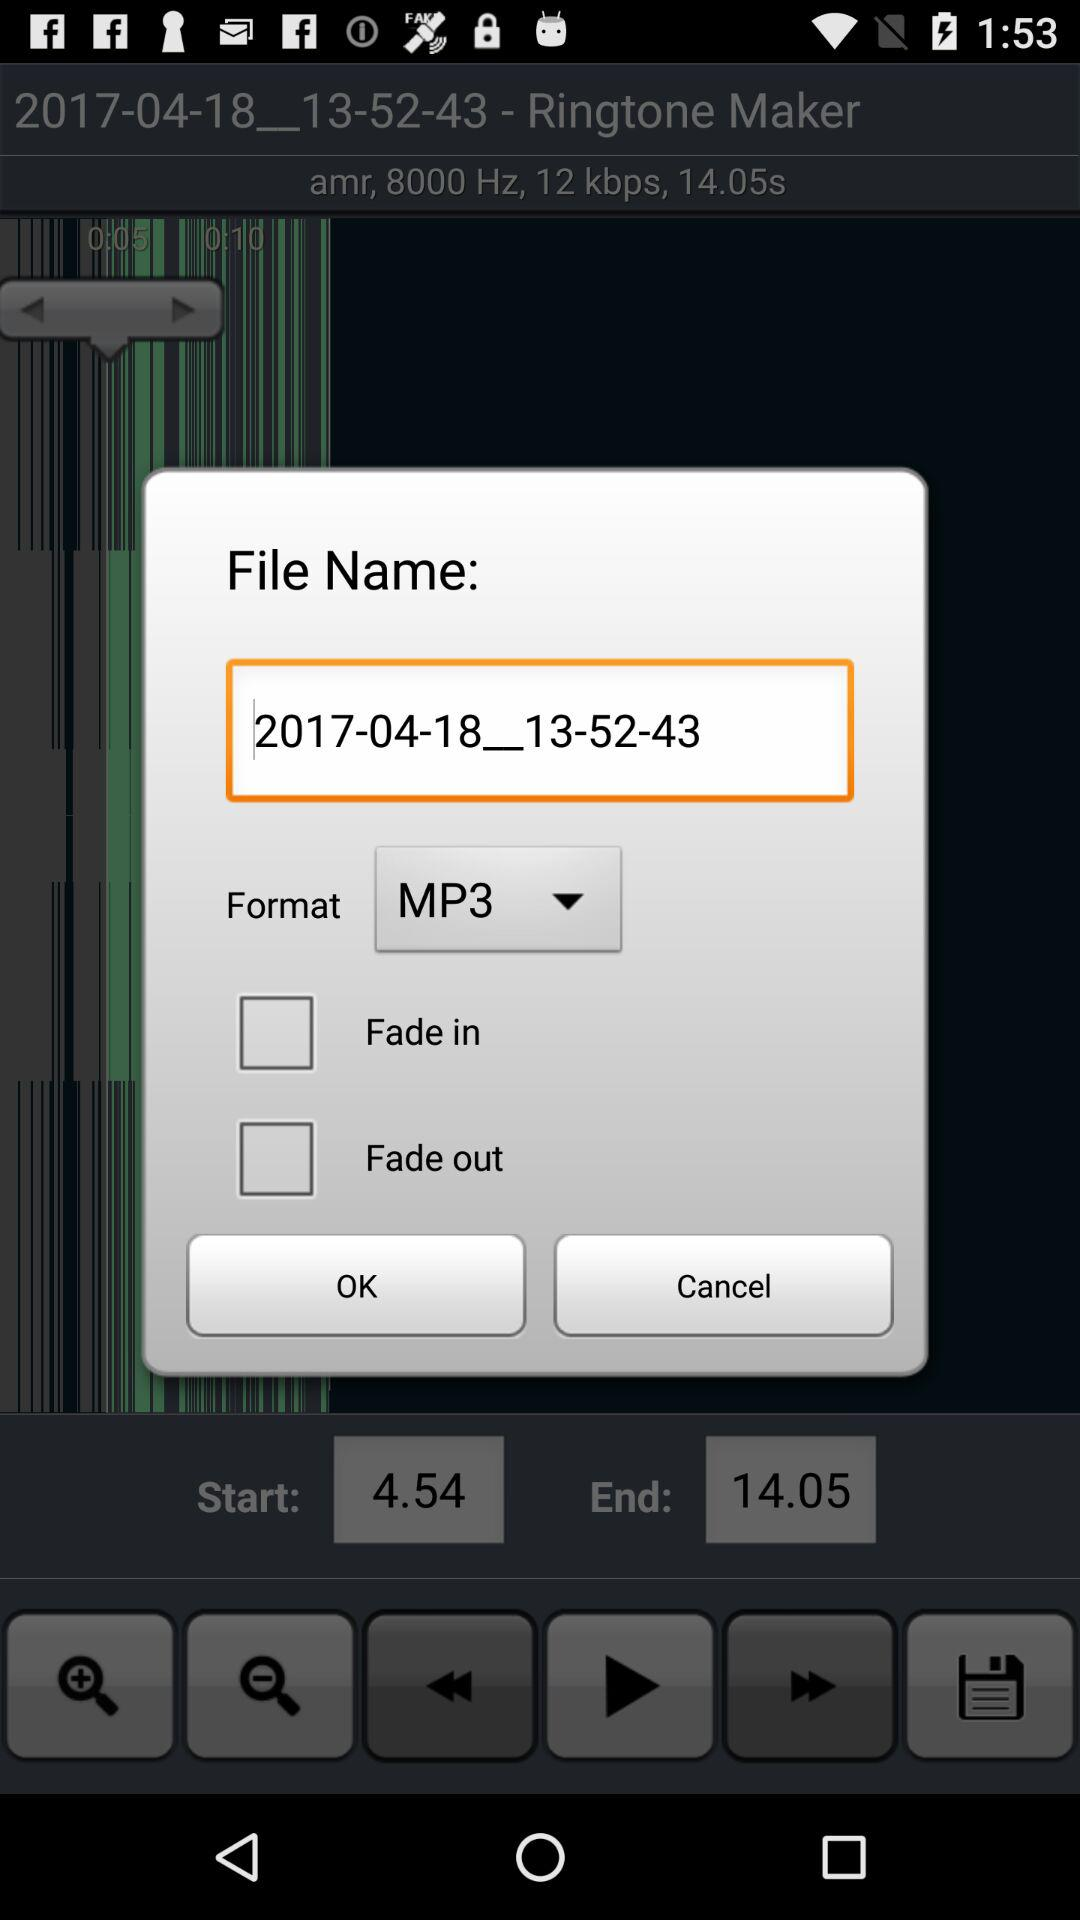What is the start time? The start time is 4.54. 